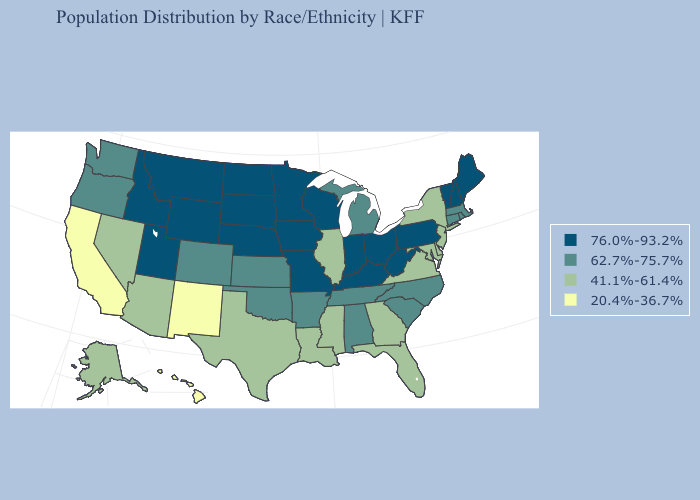Name the states that have a value in the range 41.1%-61.4%?
Be succinct. Alaska, Arizona, Delaware, Florida, Georgia, Illinois, Louisiana, Maryland, Mississippi, Nevada, New Jersey, New York, Texas, Virginia. Among the states that border Missouri , does Illinois have the lowest value?
Keep it brief. Yes. Does Kansas have a lower value than Maine?
Give a very brief answer. Yes. What is the lowest value in states that border Utah?
Short answer required. 20.4%-36.7%. Among the states that border Missouri , which have the lowest value?
Answer briefly. Illinois. What is the highest value in states that border Michigan?
Short answer required. 76.0%-93.2%. Name the states that have a value in the range 20.4%-36.7%?
Short answer required. California, Hawaii, New Mexico. Name the states that have a value in the range 20.4%-36.7%?
Be succinct. California, Hawaii, New Mexico. Is the legend a continuous bar?
Answer briefly. No. Name the states that have a value in the range 41.1%-61.4%?
Answer briefly. Alaska, Arizona, Delaware, Florida, Georgia, Illinois, Louisiana, Maryland, Mississippi, Nevada, New Jersey, New York, Texas, Virginia. What is the value of Montana?
Quick response, please. 76.0%-93.2%. Which states have the lowest value in the Northeast?
Answer briefly. New Jersey, New York. Which states have the lowest value in the West?
Give a very brief answer. California, Hawaii, New Mexico. Does South Dakota have a higher value than Minnesota?
Write a very short answer. No. Is the legend a continuous bar?
Answer briefly. No. 